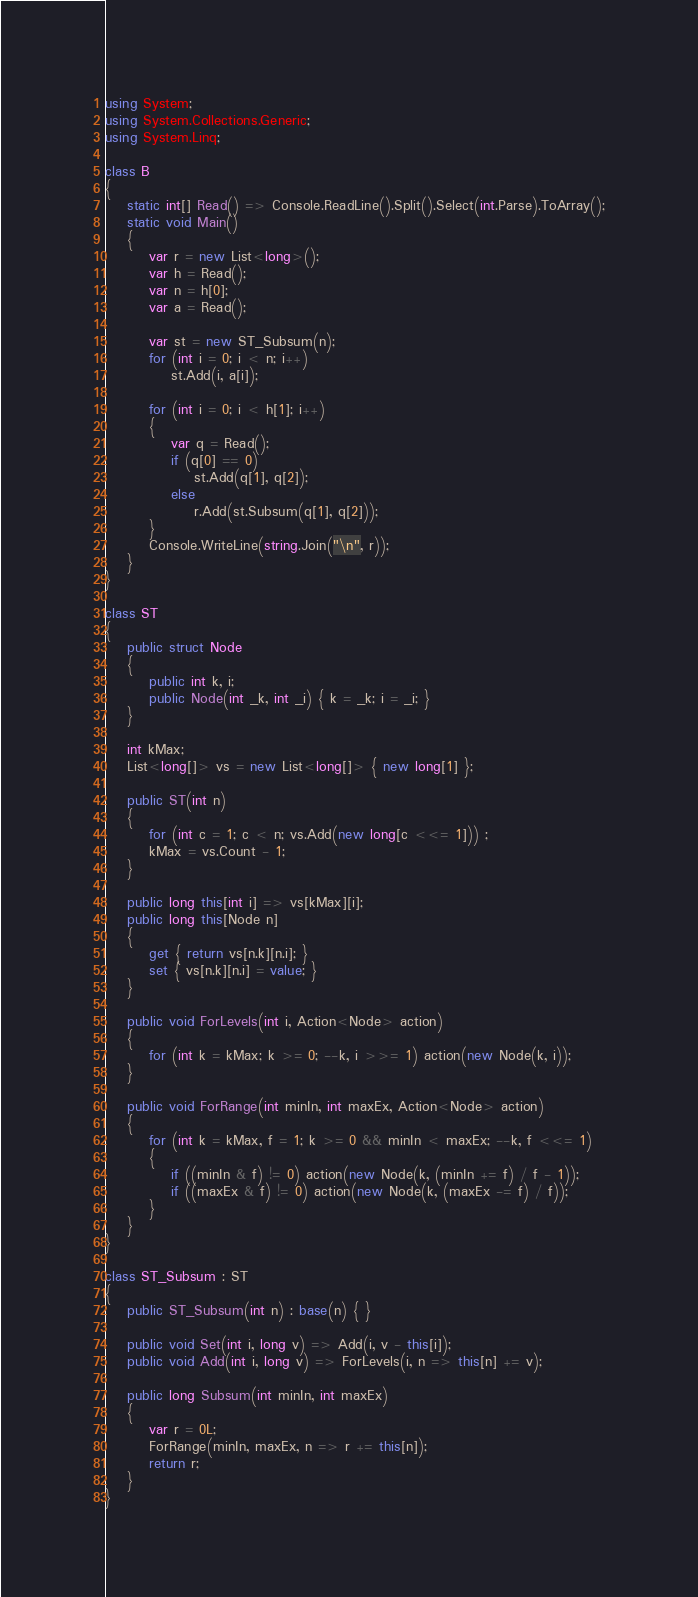<code> <loc_0><loc_0><loc_500><loc_500><_C#_>using System;
using System.Collections.Generic;
using System.Linq;

class B
{
	static int[] Read() => Console.ReadLine().Split().Select(int.Parse).ToArray();
	static void Main()
	{
		var r = new List<long>();
		var h = Read();
		var n = h[0];
		var a = Read();

		var st = new ST_Subsum(n);
		for (int i = 0; i < n; i++)
			st.Add(i, a[i]);

		for (int i = 0; i < h[1]; i++)
		{
			var q = Read();
			if (q[0] == 0)
				st.Add(q[1], q[2]);
			else
				r.Add(st.Subsum(q[1], q[2]));
		}
		Console.WriteLine(string.Join("\n", r));
	}
}

class ST
{
	public struct Node
	{
		public int k, i;
		public Node(int _k, int _i) { k = _k; i = _i; }
	}

	int kMax;
	List<long[]> vs = new List<long[]> { new long[1] };

	public ST(int n)
	{
		for (int c = 1; c < n; vs.Add(new long[c <<= 1])) ;
		kMax = vs.Count - 1;
	}

	public long this[int i] => vs[kMax][i];
	public long this[Node n]
	{
		get { return vs[n.k][n.i]; }
		set { vs[n.k][n.i] = value; }
	}

	public void ForLevels(int i, Action<Node> action)
	{
		for (int k = kMax; k >= 0; --k, i >>= 1) action(new Node(k, i));
	}

	public void ForRange(int minIn, int maxEx, Action<Node> action)
	{
		for (int k = kMax, f = 1; k >= 0 && minIn < maxEx; --k, f <<= 1)
		{
			if ((minIn & f) != 0) action(new Node(k, (minIn += f) / f - 1));
			if ((maxEx & f) != 0) action(new Node(k, (maxEx -= f) / f));
		}
	}
}

class ST_Subsum : ST
{
	public ST_Subsum(int n) : base(n) { }

	public void Set(int i, long v) => Add(i, v - this[i]);
	public void Add(int i, long v) => ForLevels(i, n => this[n] += v);

	public long Subsum(int minIn, int maxEx)
	{
		var r = 0L;
		ForRange(minIn, maxEx, n => r += this[n]);
		return r;
	}
}
</code> 